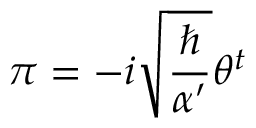Convert formula to latex. <formula><loc_0><loc_0><loc_500><loc_500>\pi = - i \sqrt { \frac { } { \alpha ^ { \prime } } } \theta ^ { t }</formula> 